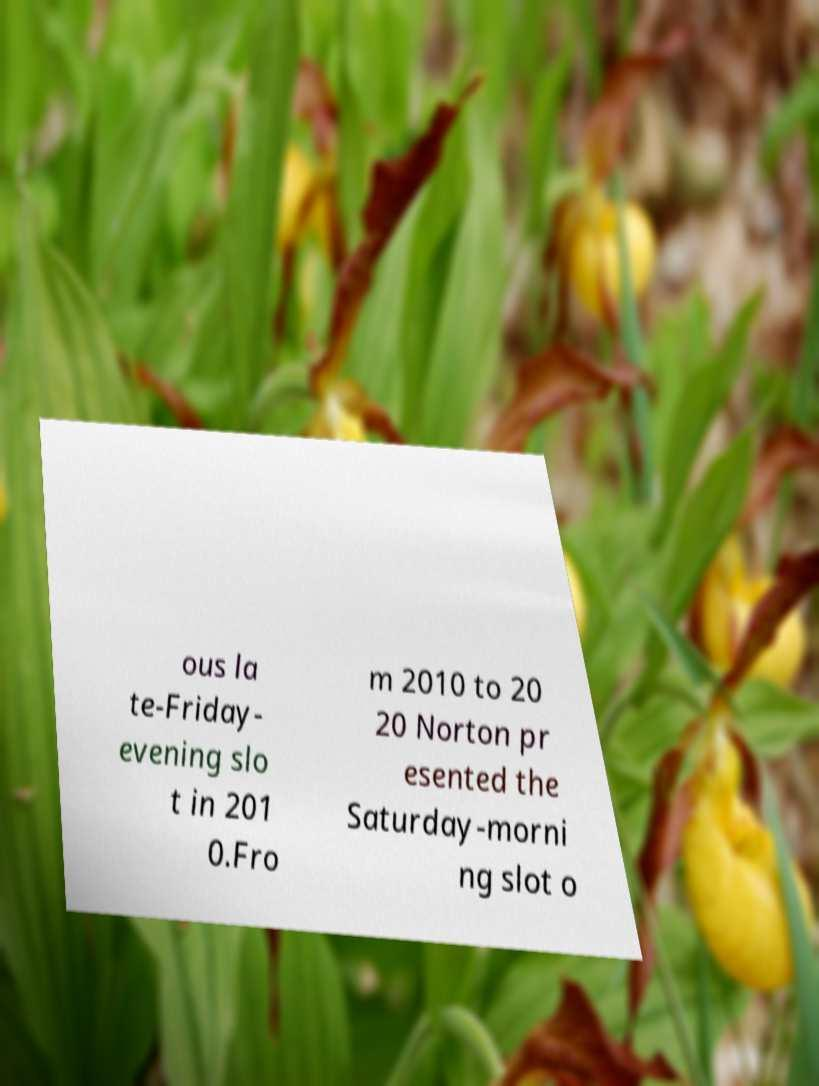I need the written content from this picture converted into text. Can you do that? ous la te-Friday- evening slo t in 201 0.Fro m 2010 to 20 20 Norton pr esented the Saturday-morni ng slot o 